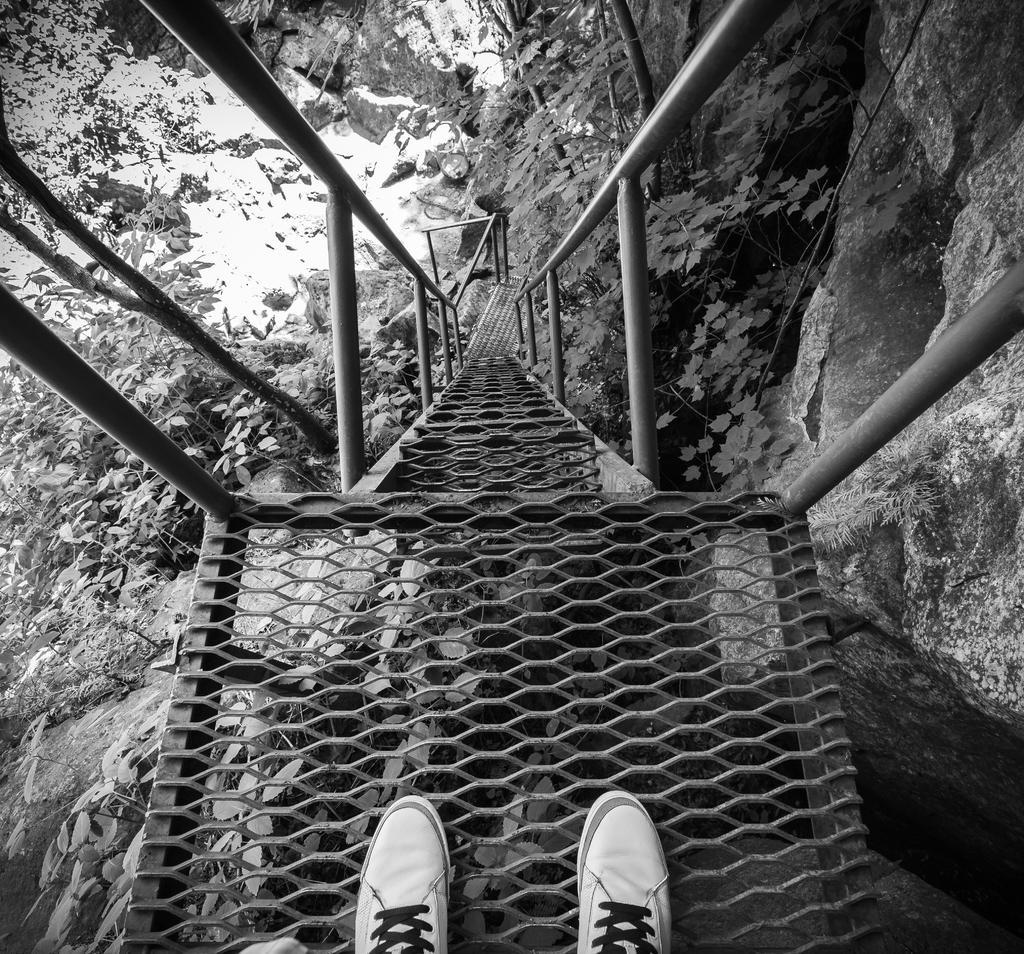Can you describe this image briefly? In this image I can see white shoes on the mesh stairs. It has railings. There are plants and rocks. This is a black and white image. 